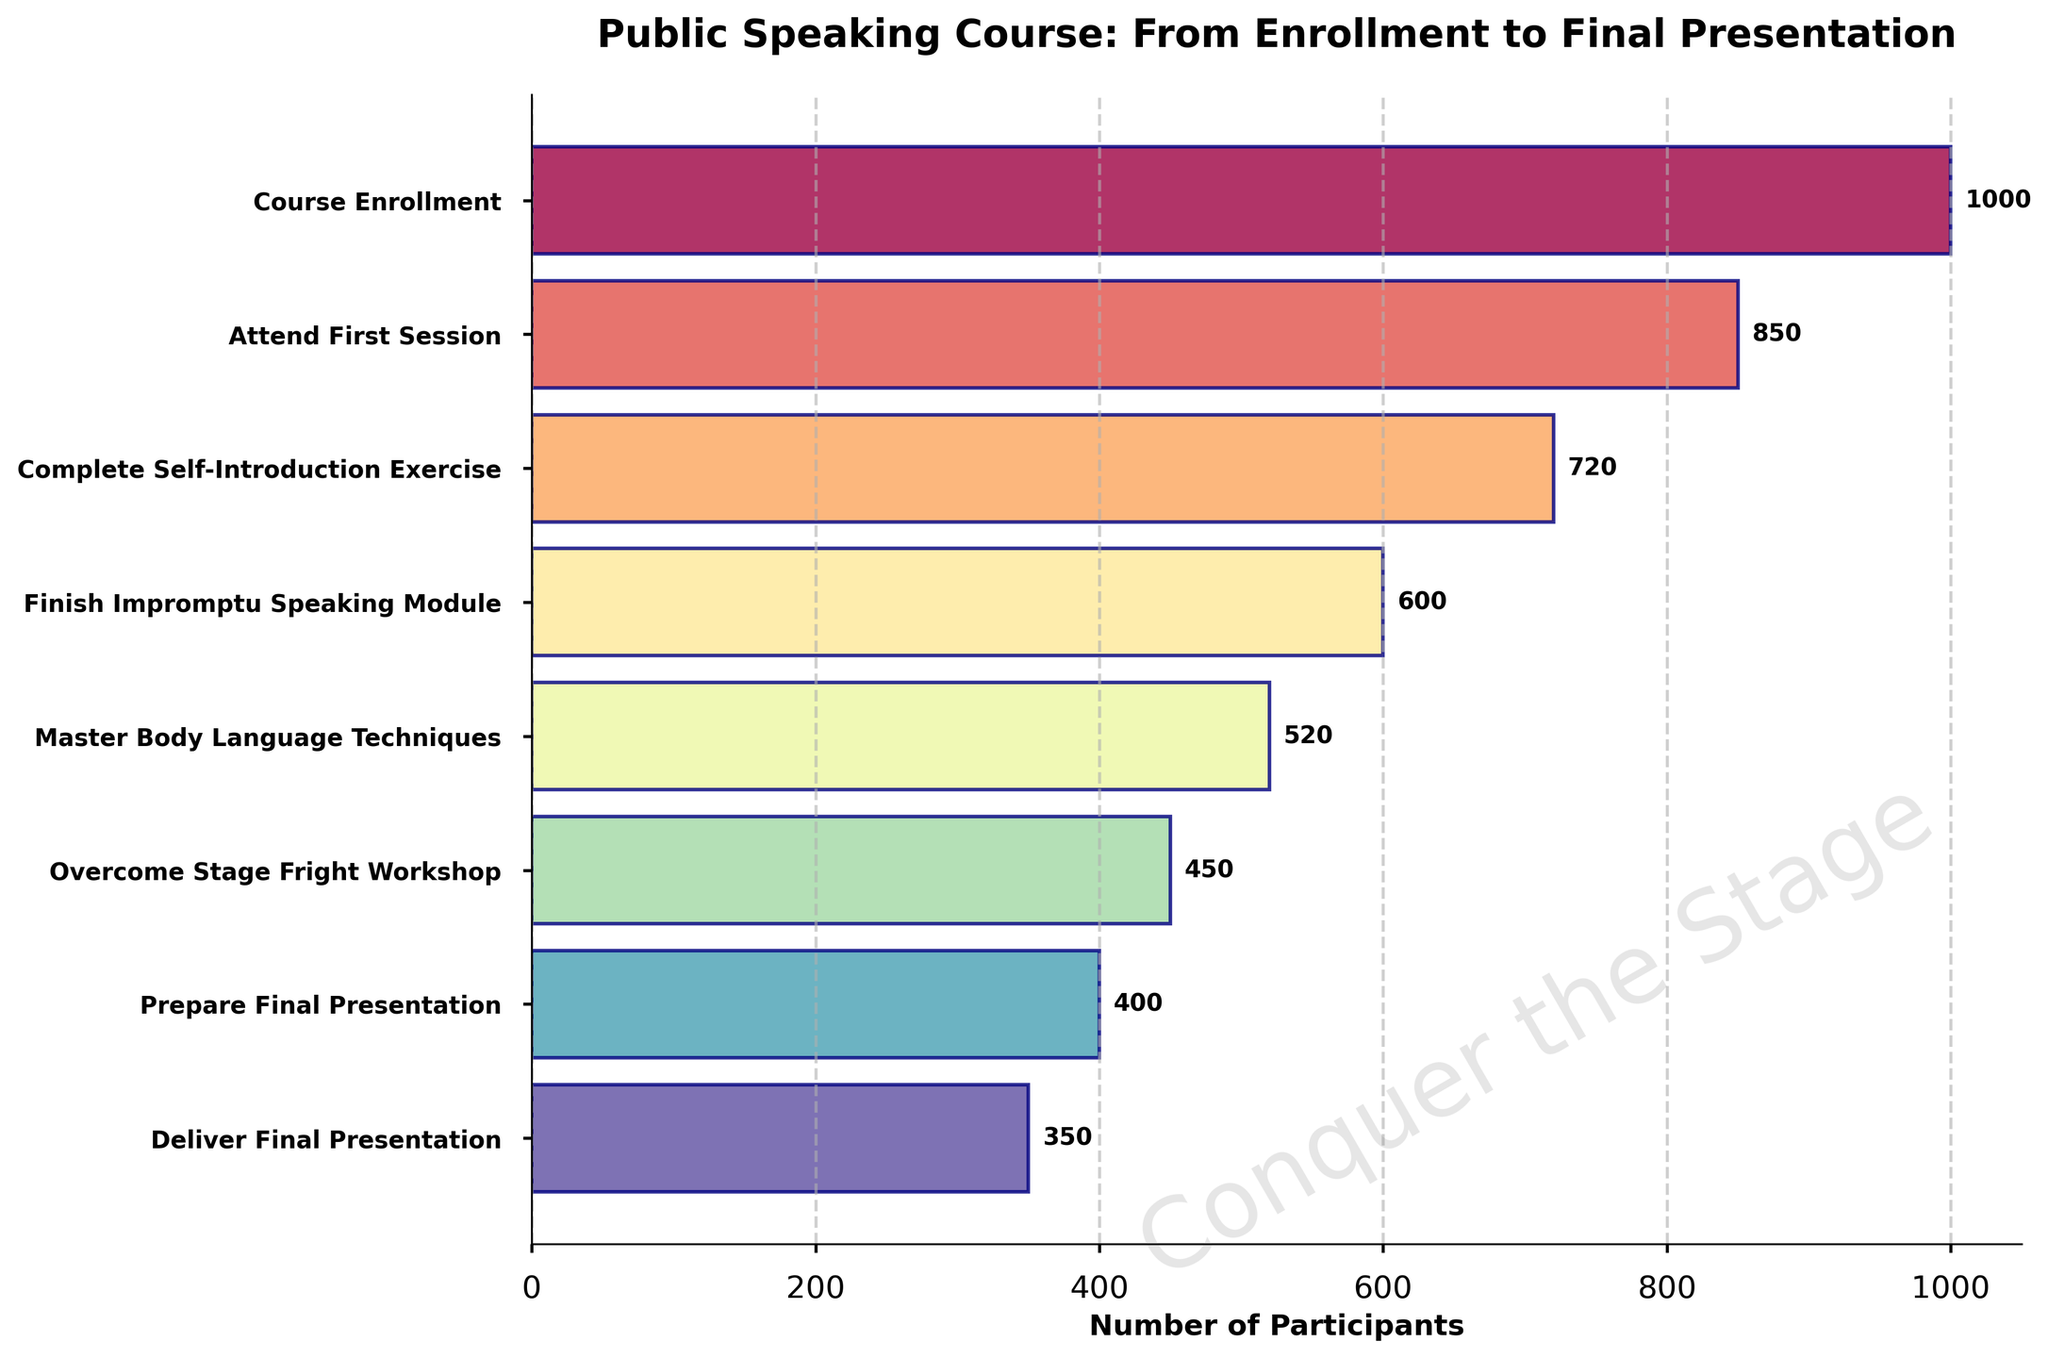How many stages are there in the funnel chart? Count the number of distinct stages listed on the vertical axis of the chart.
Answer: 8 What is the title of the funnel chart? The title of the chart is typically written at the top.
Answer: Public Speaking Course: From Enrollment to Final Presentation How many participants completed the "Master Body Language Techniques" stage? Look at the bar corresponding to the "Master Body Language Techniques" stage and read the number next to it.
Answer: 520 How many participants drop off between the "Course Enrollment" and "Attend First Session" stages? Subtract the number of participants who attend the first session (850) from the number who enrolled (1000).
Answer: 150 What is the overall drop-off rate from course enrollment to delivering the final presentation? Subtract the number of participants who deliver the final presentation (350) from the number who enrolled (1000), then divide by the number of enrollees and multiply by 100 to get the percentage.
Answer: 65% Which stage has the highest engagement after the initial enrollment? Identify the stage with the largest number of participants after the initial course enrollment.
Answer: Attend First Session What is the average number of participants who drop off at each stage? Calculate the differences in participants between each consecutive stage, sum these differences, and divide by the number of drop-off points (which is the number of stages minus one).
Answer: 93.75 Which stage has the greatest drop in participant numbers? Identify the stage where the difference in participant numbers from the previous stage is the largest by comparing the values at each transition.
Answer: Attend First Session to Complete Self-Introduction Exercise How many more participants completed the "Impromptu Speaking Module" than the "Overcome Stage Fright Workshop"? Subtract the number of participants at the "Overcome Stage Fright Workshop" stage (450) from those who completed the "Impromptu Speaking Module" (600).
Answer: 150 How does the number of participants who deliver the final presentation compare to those who prepare the final presentation? Compare the participant numbers at the "Deliver Final Presentation" (350) and "Prepare Final Presentation" (400) stages.
Answer: 50 less 